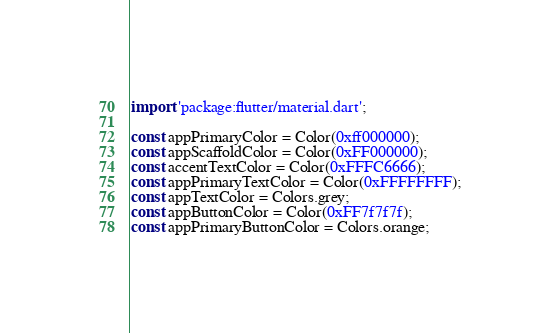<code> <loc_0><loc_0><loc_500><loc_500><_Dart_>

import 'package:flutter/material.dart';

const appPrimaryColor = Color(0xff000000);
const appScaffoldColor = Color(0xFF000000);
const accentTextColor = Color(0xFFFC6666);
const appPrimaryTextColor = Color(0xFFFFFFFF);
const appTextColor = Colors.grey;
const appButtonColor = Color(0xFF7f7f7f);
const appPrimaryButtonColor = Colors.orange;
</code> 